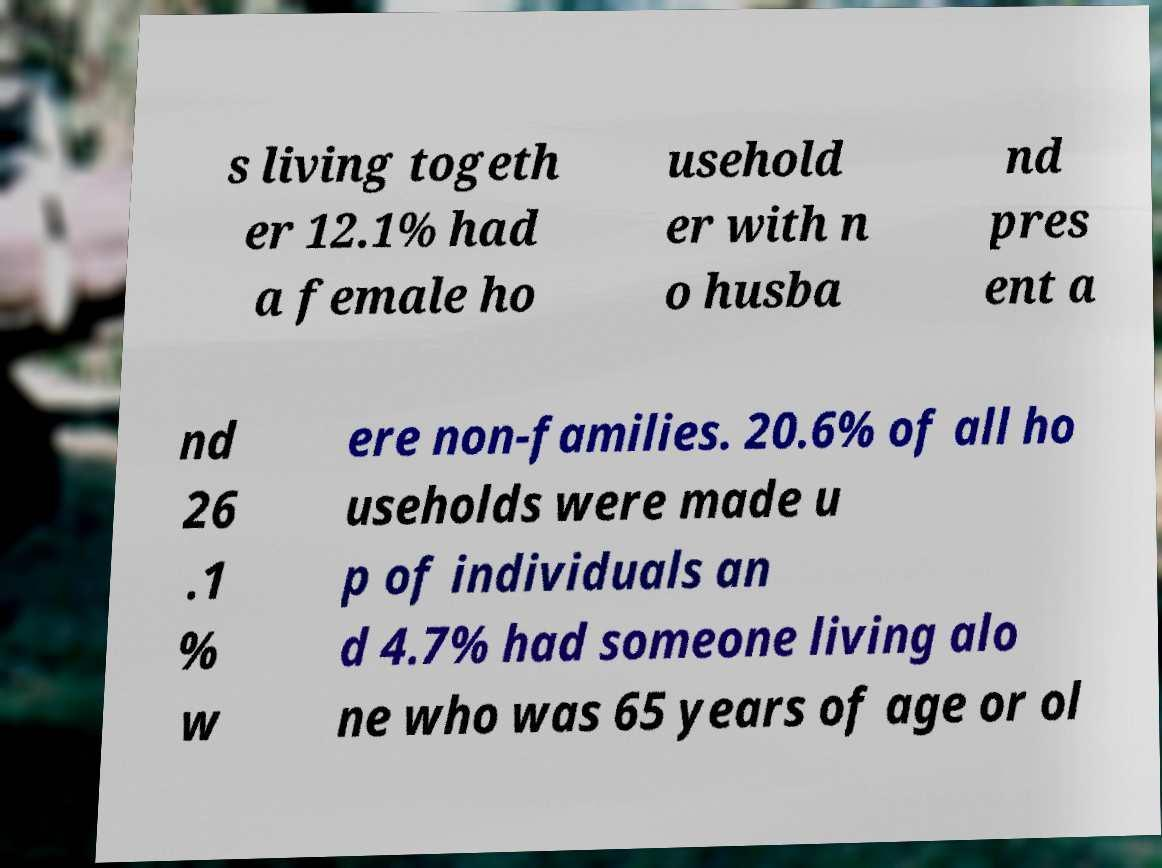Could you assist in decoding the text presented in this image and type it out clearly? s living togeth er 12.1% had a female ho usehold er with n o husba nd pres ent a nd 26 .1 % w ere non-families. 20.6% of all ho useholds were made u p of individuals an d 4.7% had someone living alo ne who was 65 years of age or ol 